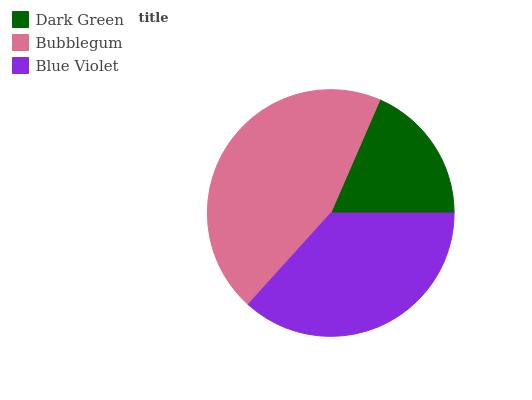Is Dark Green the minimum?
Answer yes or no. Yes. Is Bubblegum the maximum?
Answer yes or no. Yes. Is Blue Violet the minimum?
Answer yes or no. No. Is Blue Violet the maximum?
Answer yes or no. No. Is Bubblegum greater than Blue Violet?
Answer yes or no. Yes. Is Blue Violet less than Bubblegum?
Answer yes or no. Yes. Is Blue Violet greater than Bubblegum?
Answer yes or no. No. Is Bubblegum less than Blue Violet?
Answer yes or no. No. Is Blue Violet the high median?
Answer yes or no. Yes. Is Blue Violet the low median?
Answer yes or no. Yes. Is Bubblegum the high median?
Answer yes or no. No. Is Dark Green the low median?
Answer yes or no. No. 